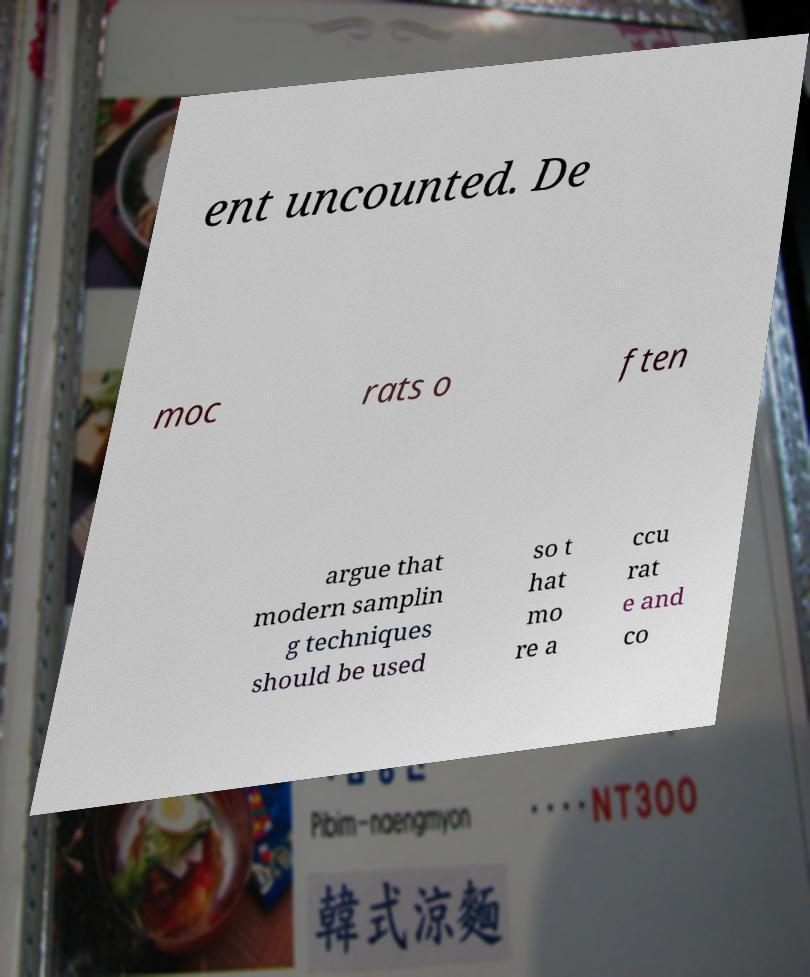For documentation purposes, I need the text within this image transcribed. Could you provide that? ent uncounted. De moc rats o ften argue that modern samplin g techniques should be used so t hat mo re a ccu rat e and co 